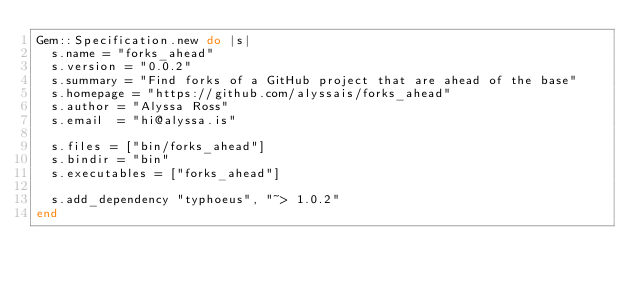<code> <loc_0><loc_0><loc_500><loc_500><_Ruby_>Gem::Specification.new do |s|
  s.name = "forks_ahead"
  s.version = "0.0.2"
  s.summary = "Find forks of a GitHub project that are ahead of the base"
  s.homepage = "https://github.com/alyssais/forks_ahead"
  s.author = "Alyssa Ross"
  s.email  = "hi@alyssa.is"

  s.files = ["bin/forks_ahead"]
  s.bindir = "bin"
  s.executables = ["forks_ahead"]

  s.add_dependency "typhoeus", "~> 1.0.2"
end
</code> 